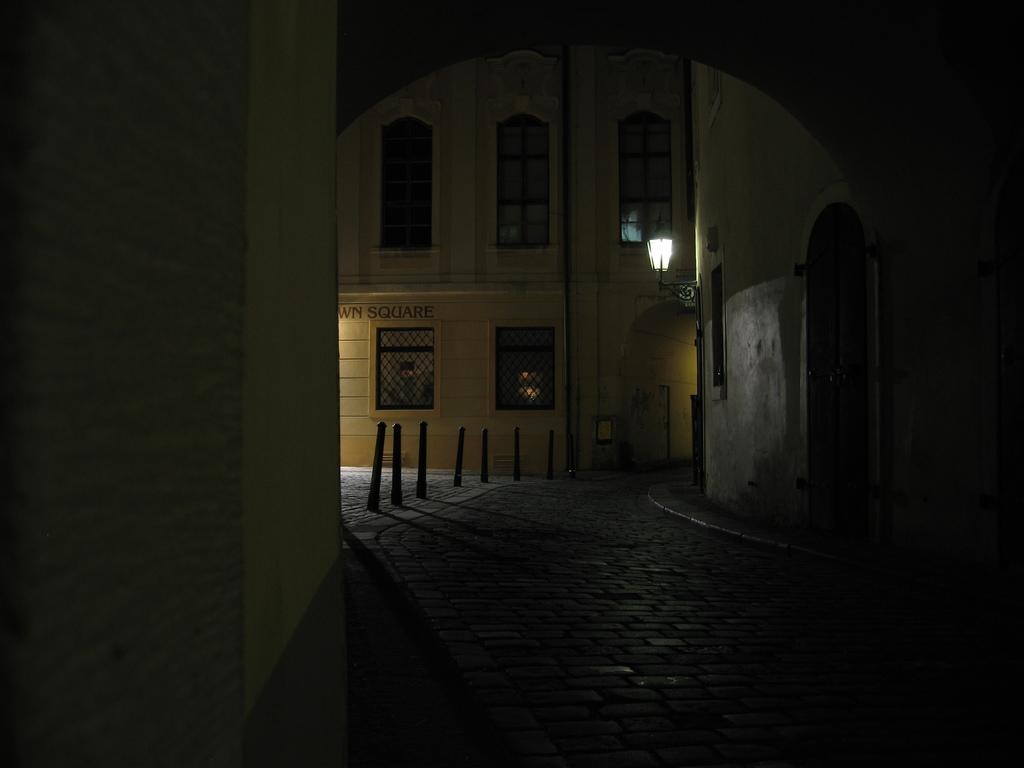What is one of the main structures in the image? There is a wall in the image. What can be seen on the road in the image? There are poles on the road in the image. What is the source of illumination in the image? There is a light in the image. What type of buildings can be seen in the background of the image? There are buildings with windows in the background of the image. Where is the fireman standing in the image? There is no fireman present in the image. What type of pipe can be seen running along the wall in the image? There is no pipe visible in the image. 